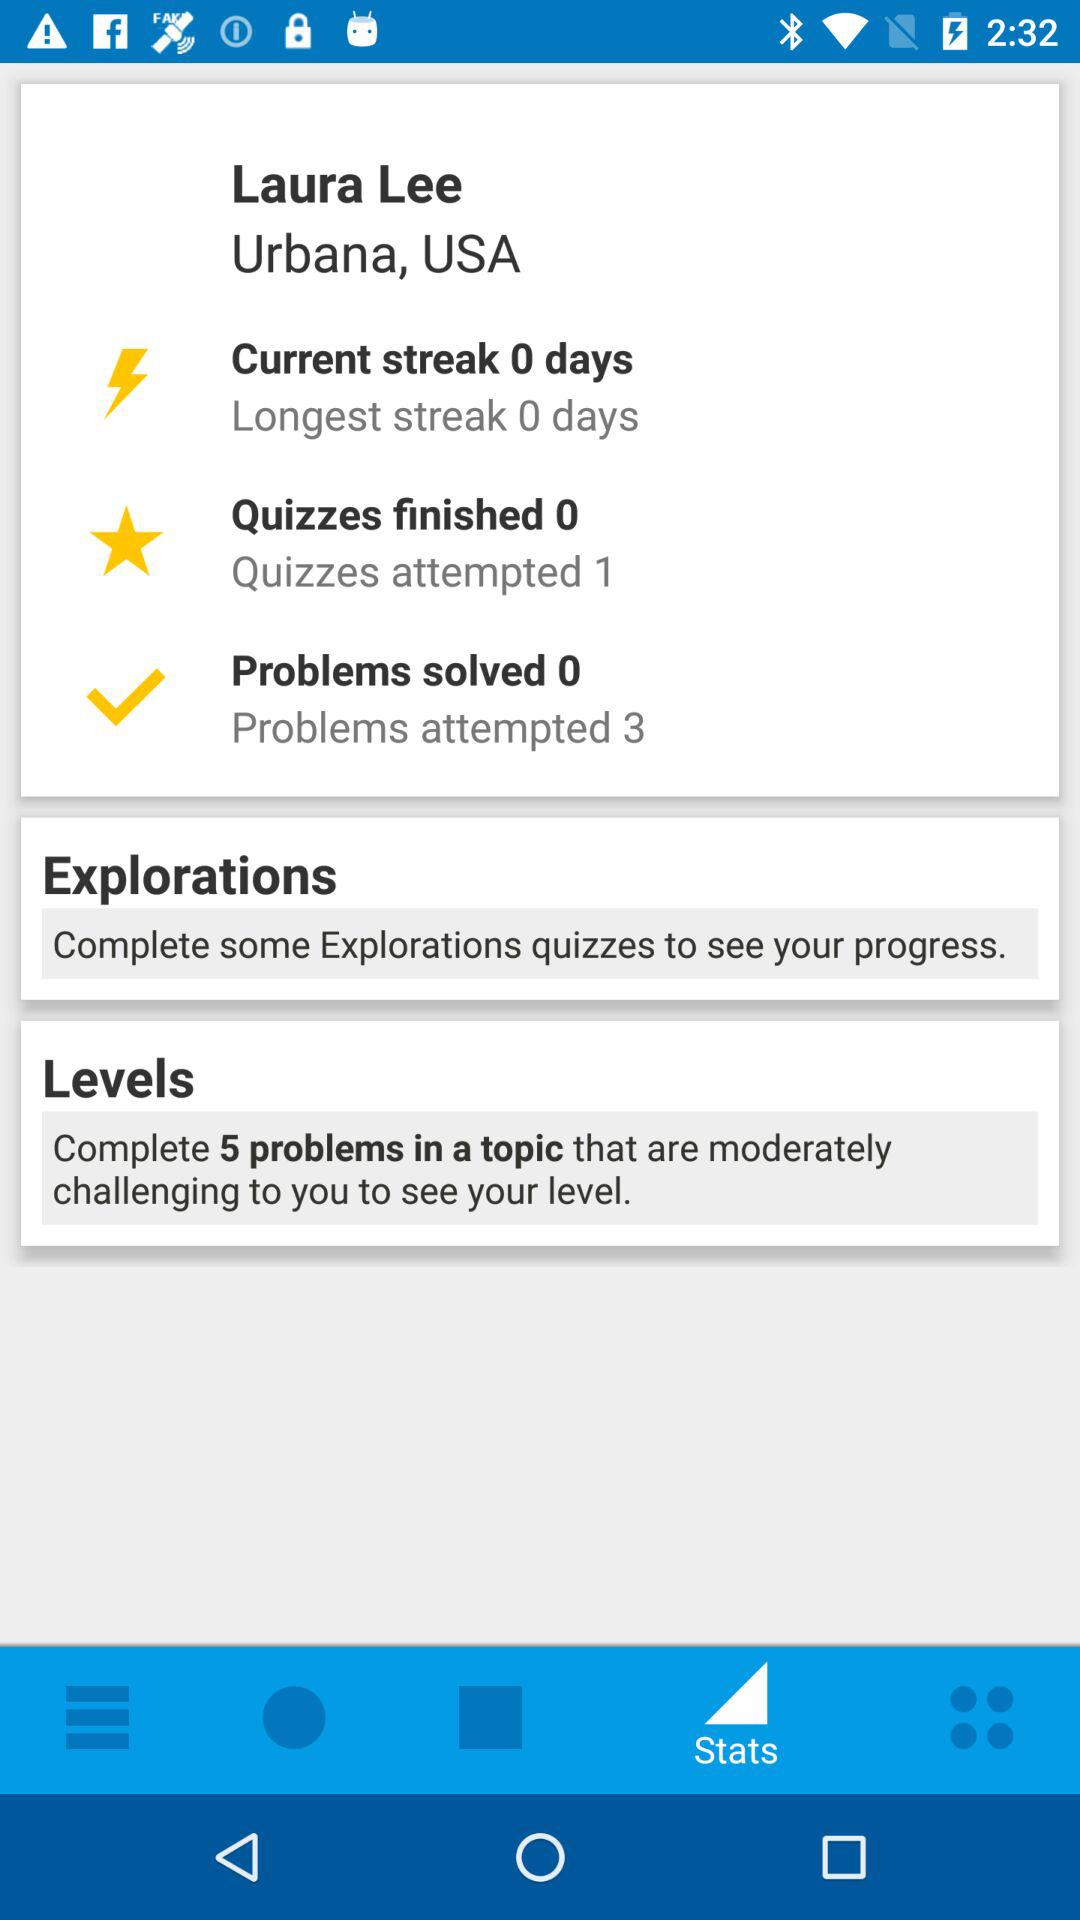How many more problems have been attempted than solved?
Answer the question using a single word or phrase. 3 